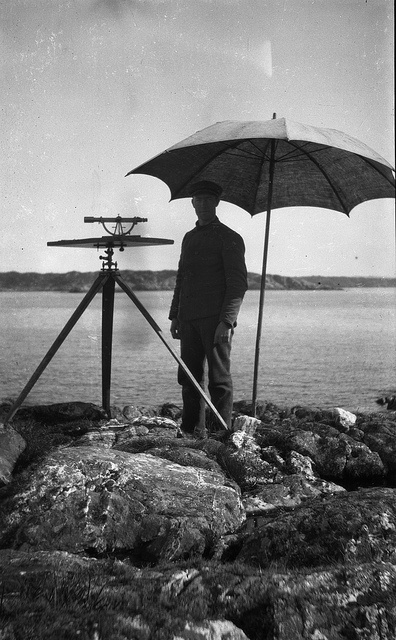Describe the objects in this image and their specific colors. I can see umbrella in darkgray, black, and lightgray tones and people in darkgray, black, gray, and lightgray tones in this image. 